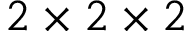Convert formula to latex. <formula><loc_0><loc_0><loc_500><loc_500>2 \times 2 \times 2</formula> 